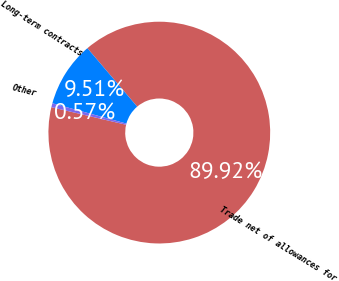<chart> <loc_0><loc_0><loc_500><loc_500><pie_chart><fcel>Trade net of allowances for<fcel>Long-term contracts<fcel>Other<nl><fcel>89.92%<fcel>9.51%<fcel>0.57%<nl></chart> 